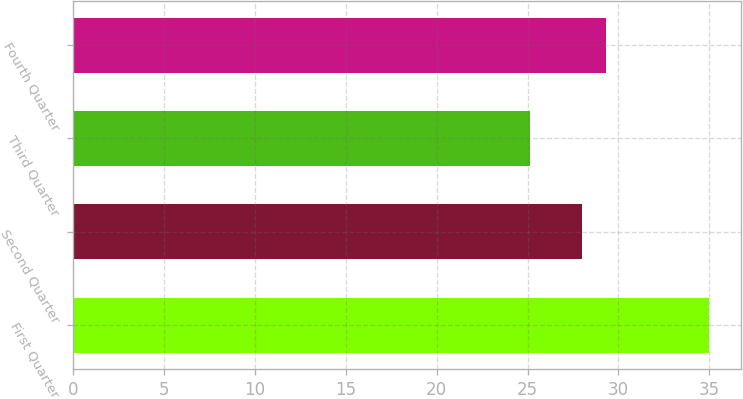Convert chart to OTSL. <chart><loc_0><loc_0><loc_500><loc_500><bar_chart><fcel>First Quarter<fcel>Second Quarter<fcel>Third Quarter<fcel>Fourth Quarter<nl><fcel>35.01<fcel>28.02<fcel>25.11<fcel>29.3<nl></chart> 